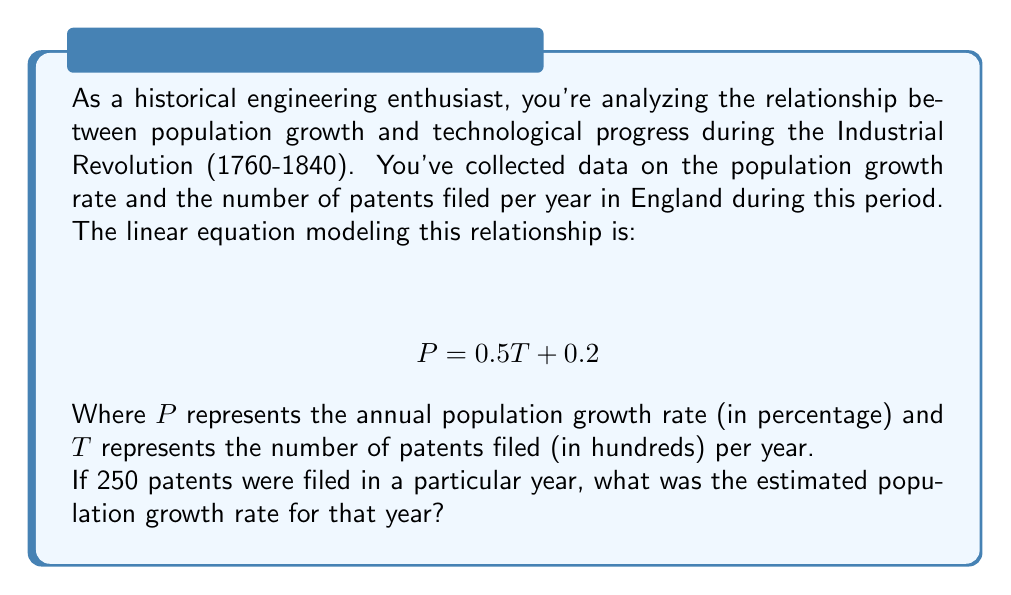Teach me how to tackle this problem. To solve this problem, we need to use the given linear equation and substitute the known value for T. Let's break it down step-by-step:

1. We're given the linear equation:
   $$ P = 0.5T + 0.2 $$

2. We know that 250 patents were filed in the year we're interested in. However, the equation uses T in hundreds of patents, so we need to convert 250 to 2.5 hundreds:
   $$ T = 2.5 $$

3. Now, let's substitute this value into our equation:
   $$ P = 0.5(2.5) + 0.2 $$

4. Let's solve the equation:
   $$ P = 1.25 + 0.2 $$
   $$ P = 1.45 $$

5. Therefore, the estimated population growth rate for that year was 1.45%.

This result suggests that during the Industrial Revolution, there was a positive correlation between technological progress (as measured by patent filings) and population growth. This aligns with historical observations that technological advancements often led to improved living conditions, better healthcare, and increased food production, which in turn supported population growth.
Answer: The estimated population growth rate for the year when 250 patents were filed was 1.45%. 